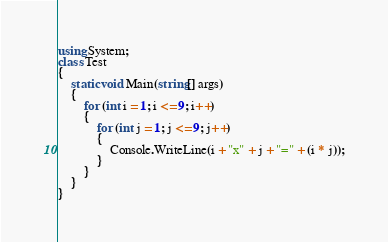<code> <loc_0><loc_0><loc_500><loc_500><_C#_>using System;
class Test
{
	static void Main(string[] args)
	{
		for (int i = 1; i <= 9; i++)
		{
			for (int j = 1; j <= 9; j++)
			{
				Console.WriteLine(i + "x" + j + "=" + (i * j));
			}
		}
	}
}</code> 